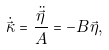Convert formula to latex. <formula><loc_0><loc_0><loc_500><loc_500>\dot { \vec { \kappa } } = \frac { \ddot { \vec { \eta } } } { A } = - B \vec { \eta } ,</formula> 